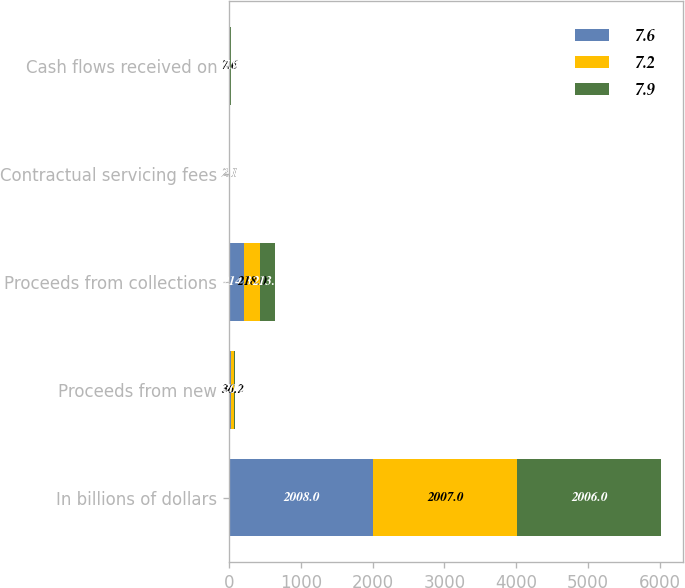Convert chart. <chart><loc_0><loc_0><loc_500><loc_500><stacked_bar_chart><ecel><fcel>In billions of dollars<fcel>Proceeds from new<fcel>Proceeds from collections<fcel>Contractual servicing fees<fcel>Cash flows received on<nl><fcel>7.6<fcel>2008<fcel>28.7<fcel>214.3<fcel>2<fcel>7.2<nl><fcel>7.2<fcel>2007<fcel>36.2<fcel>218<fcel>2.1<fcel>7.6<nl><fcel>7.9<fcel>2006<fcel>20.2<fcel>213.1<fcel>2.1<fcel>7.9<nl></chart> 